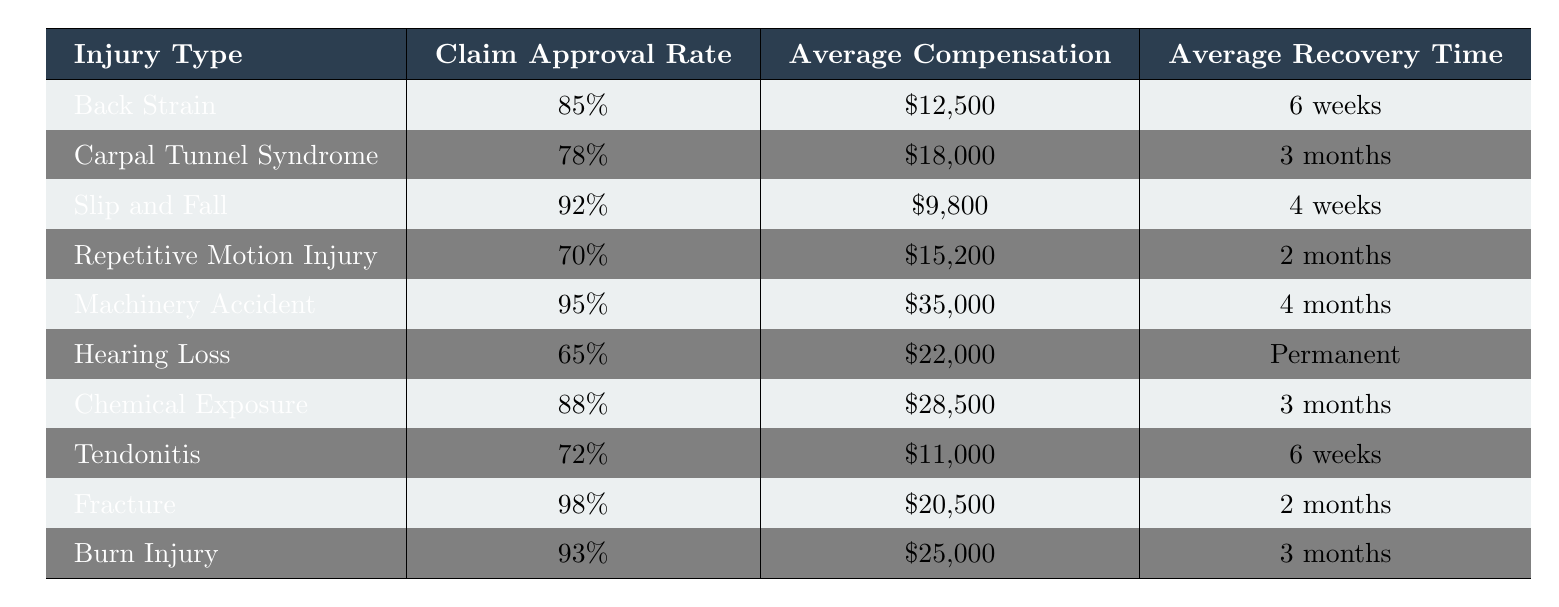What is the claim approval rate for "Carpal Tunnel Syndrome"? The table indicates that the claim approval rate for "Carpal Tunnel Syndrome" is specified next to this injury type, which is 78%.
Answer: 78% Which injury type has the highest average compensation amount? By examining the average compensation amounts listed in the table, "Machinery Accident" has the highest amount at $35,000.
Answer: $35,000 What is the average recovery time for "Hearing Loss"? The table lists the average recovery time for "Hearing Loss" as "Permanent," which means there isn't a defined recovery period.
Answer: Permanent How does the claim approval rate for "Slip and Fall" compare to "Hearing Loss"? The claim approval rate for "Slip and Fall" is 92%, while for "Hearing Loss" it is 65%. Therefore, "Slip and Fall" has a higher approval rate by subtracting 65% from 92%, resulting in a difference of 27%.
Answer: 27% higher Which injury type has the lowest claim approval rate? When analyzing the claim approval rates, "Hearing Loss" has the lowest rate at 65%.
Answer: Hearing Loss What is the average recovery time for injuries with a claim approval rate above 80%? First, identify the injuries with approval rates above 80%: "Back Strain" (6 weeks), "Slip and Fall" (4 weeks), "Machinery Accident" (4 months), "Chemical Exposure" (3 months), and "Burn Injury" (3 months). The average recovery time is calculated by converting all periods to weeks: (6 + 4 + 16 + 12 + 12) / 5 = 10 weeks.
Answer: 10 weeks Is the average compensation amount for "Repetitive Motion Injury" greater than $15,000? The table specifies that the average compensation amount for "Repetitive Motion Injury" is $15,200, which is indeed greater than $15,000.
Answer: Yes How many injury types have claim approval rates of 90% or higher? The table shows "Slip and Fall" (92%), "Machinery Accident" (95%), and "Fracture" (98%). By counting these entries, there are three injury types with approval rates of 90% or higher.
Answer: 3 What is the difference in average compensation between "Burn Injury" and "Fracture"? The average compensation for "Burn Injury" is $25,000 and for "Fracture," it is $20,500. The difference is calculated as $25,000 - $20,500 = $4,500.
Answer: $4,500 Which injury type has the shortest average recovery time? The table lists "Slip and Fall" with an average recovery time of 4 weeks, which is the shortest compared to others.
Answer: Slip and Fall Is the average recovery time for "Tendonitis" the same as that for "Back Strain"? The average recovery time for "Tendonitis" is 6 weeks and for "Back Strain," it is also 6 weeks, making them the same.
Answer: Yes 